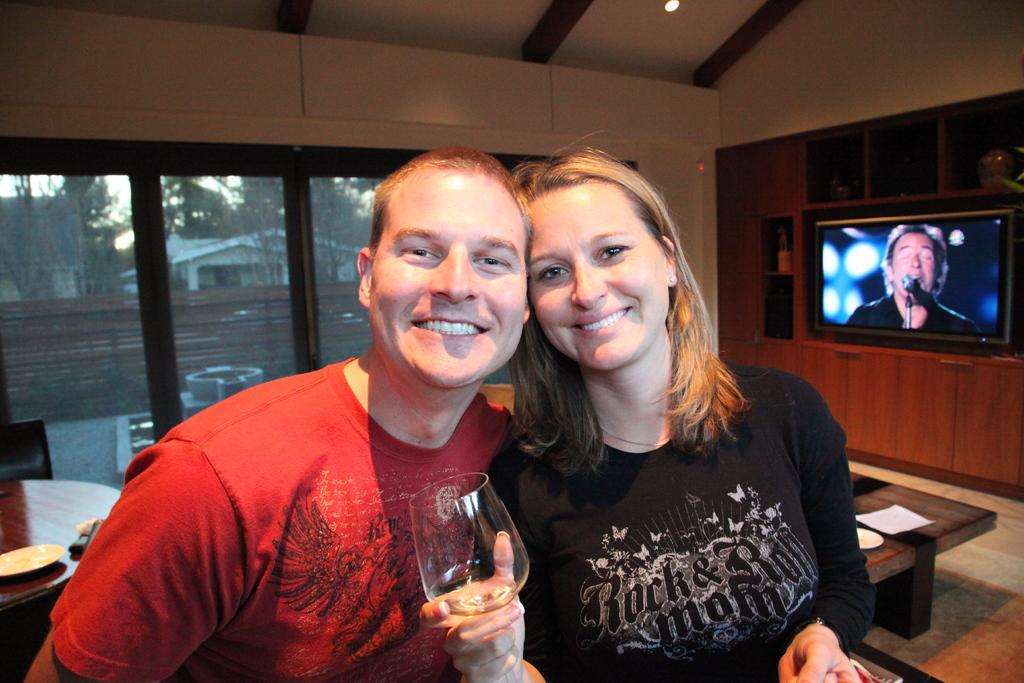How many people are present in the image? There are two people, a man and a woman, present in the image. What expressions do the man and woman have in the image? Both the man and the woman are smiling in the image. What is the woman holding in her hand? The woman is holding a glass in her hand. What can be seen in the background of the image? There is a TV, a table, and a wall in the background of the image. What type of texture can be seen on the man's shirt in the image? There is no information about the texture of the man's shirt in the image, as the facts provided do not mention it. 